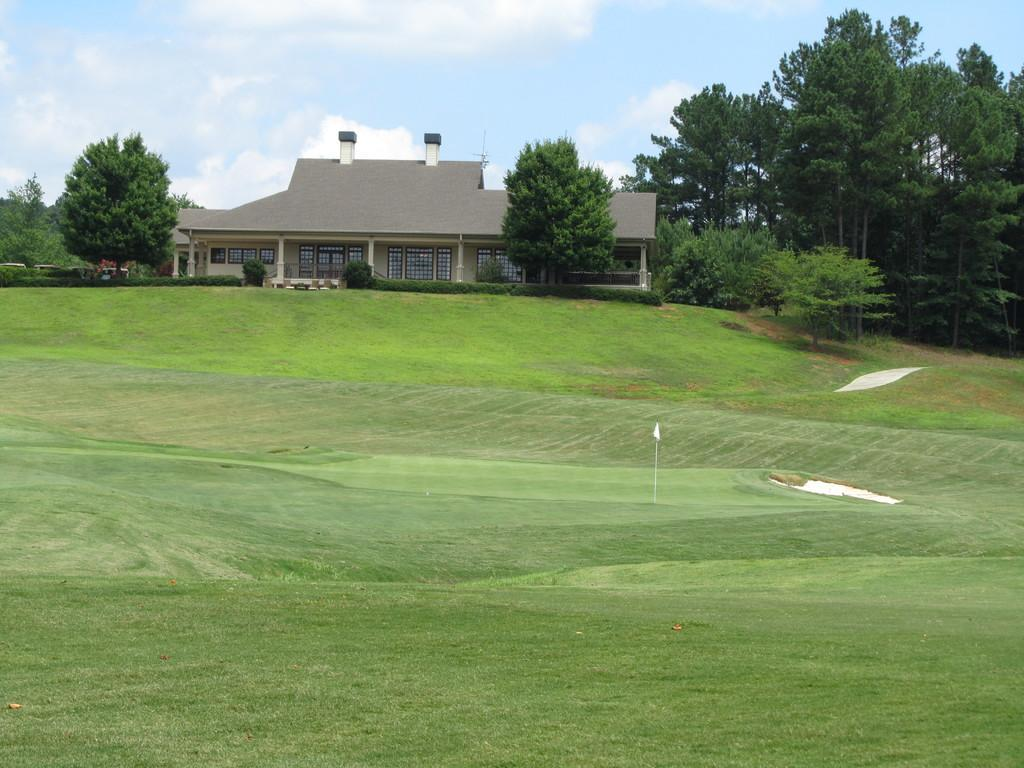What is the main subject of the image? The main subject of the image is a golf court. What can be seen in the background of the image? There is a house and trees in the background of the image. What is visible above the golf court and the background? The sky is visible in the background of the image. How many feet of snow can be seen on the golf court in the image? There is no snow present on the golf court in the image. 